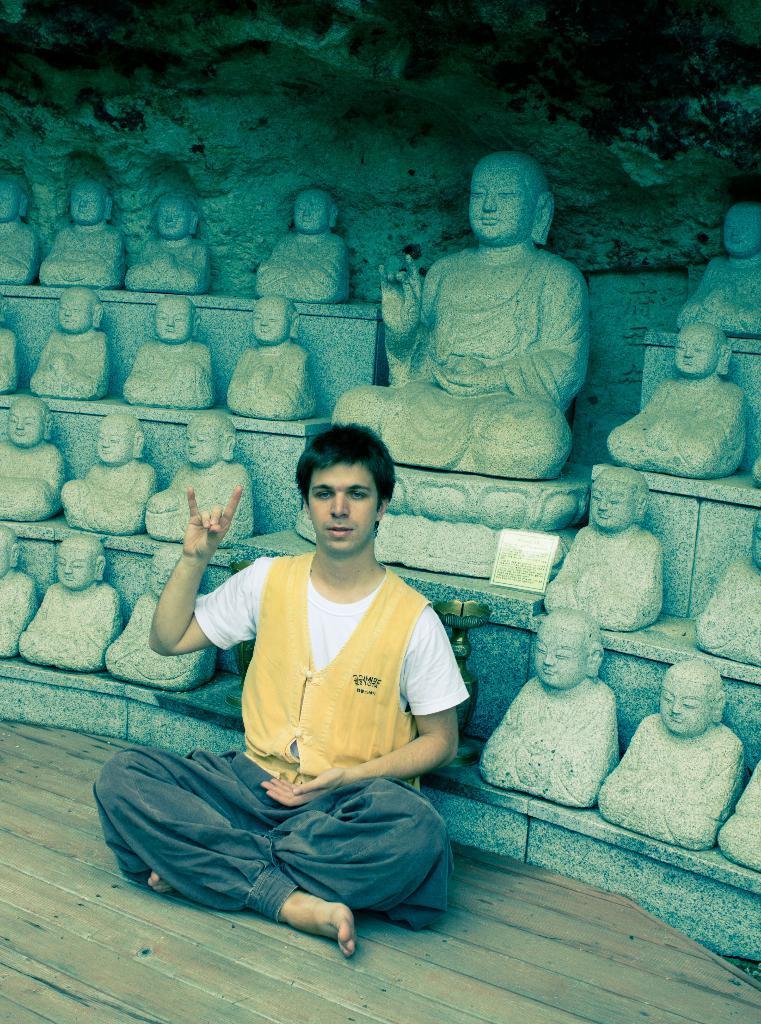Could you give a brief overview of what you see in this image? In this image we can see a person sitting on the ground. In the background, we can see a group of statues, a stand and a board with some text. 